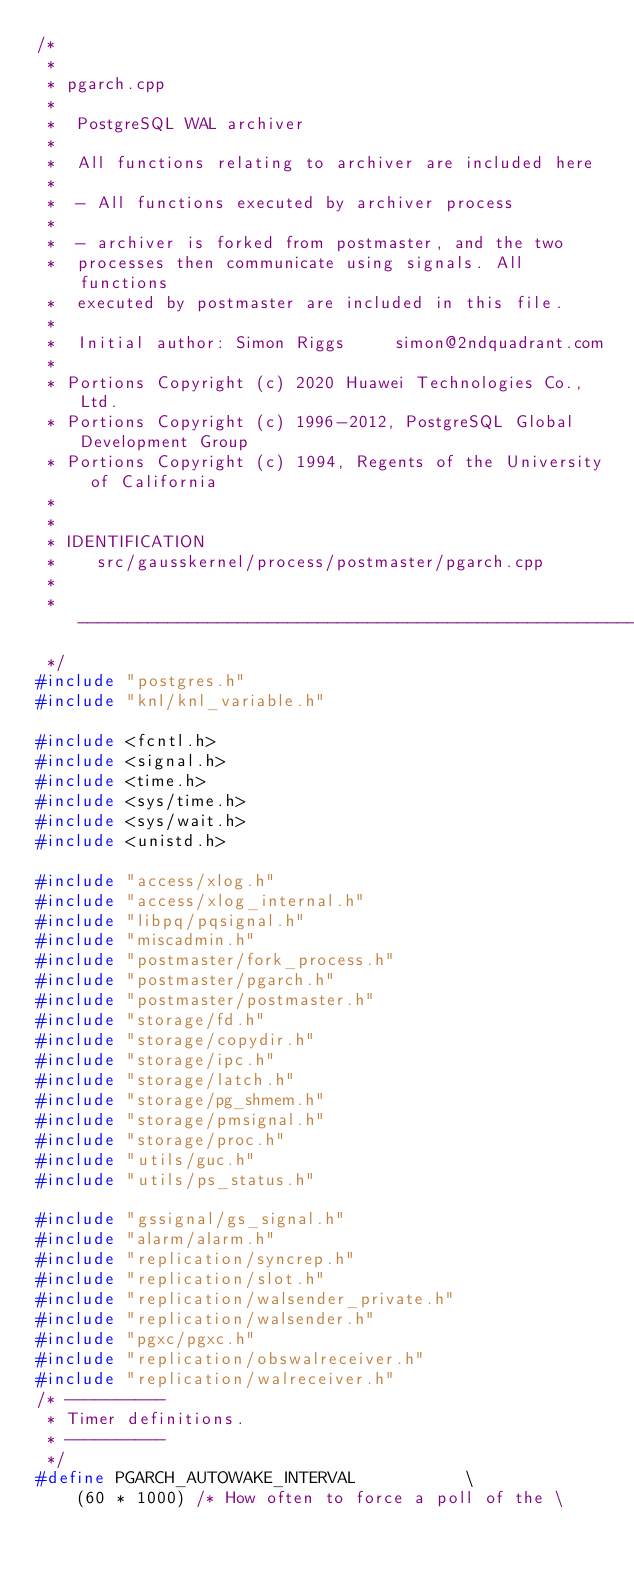<code> <loc_0><loc_0><loc_500><loc_500><_C++_>/*
 *
 * pgarch.cpp
 *
 *	PostgreSQL WAL archiver
 *
 *	All functions relating to archiver are included here
 *
 *	- All functions executed by archiver process
 *
 *	- archiver is forked from postmaster, and the two
 *	processes then communicate using signals. All functions
 *	executed by postmaster are included in this file.
 *
 *	Initial author: Simon Riggs		simon@2ndquadrant.com
 *
 * Portions Copyright (c) 2020 Huawei Technologies Co.,Ltd.
 * Portions Copyright (c) 1996-2012, PostgreSQL Global Development Group
 * Portions Copyright (c) 1994, Regents of the University of California
 *
 *
 * IDENTIFICATION
 *	  src/gausskernel/process/postmaster/pgarch.cpp
 *
 * -------------------------------------------------------------------------
 */
#include "postgres.h"
#include "knl/knl_variable.h"

#include <fcntl.h>
#include <signal.h>
#include <time.h>
#include <sys/time.h>
#include <sys/wait.h>
#include <unistd.h>

#include "access/xlog.h"
#include "access/xlog_internal.h"
#include "libpq/pqsignal.h"
#include "miscadmin.h"
#include "postmaster/fork_process.h"
#include "postmaster/pgarch.h"
#include "postmaster/postmaster.h"
#include "storage/fd.h"
#include "storage/copydir.h"
#include "storage/ipc.h"
#include "storage/latch.h"
#include "storage/pg_shmem.h"
#include "storage/pmsignal.h"
#include "storage/proc.h"
#include "utils/guc.h"
#include "utils/ps_status.h"

#include "gssignal/gs_signal.h"
#include "alarm/alarm.h"
#include "replication/syncrep.h"
#include "replication/slot.h"
#include "replication/walsender_private.h"
#include "replication/walsender.h"
#include "pgxc/pgxc.h"
#include "replication/obswalreceiver.h"
#include "replication/walreceiver.h"
/* ----------
 * Timer definitions.
 * ----------
 */
#define PGARCH_AUTOWAKE_INTERVAL           \
    (60 * 1000) /* How often to force a poll of the \</code> 